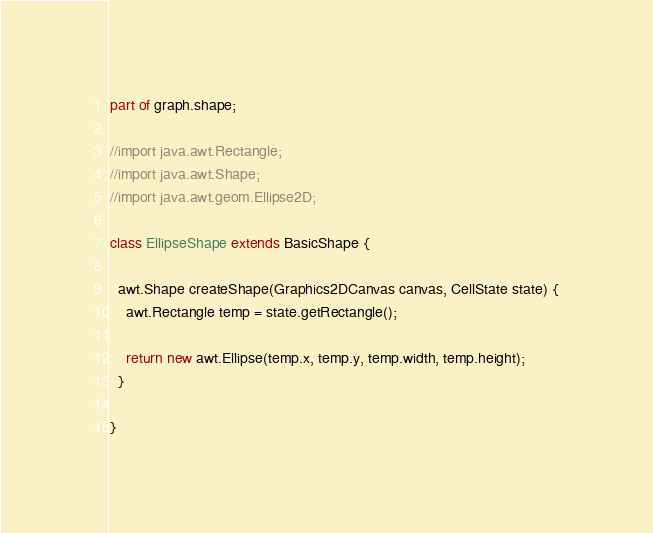Convert code to text. <code><loc_0><loc_0><loc_500><loc_500><_Dart_>part of graph.shape;

//import java.awt.Rectangle;
//import java.awt.Shape;
//import java.awt.geom.Ellipse2D;

class EllipseShape extends BasicShape {

  awt.Shape createShape(Graphics2DCanvas canvas, CellState state) {
    awt.Rectangle temp = state.getRectangle();

    return new awt.Ellipse(temp.x, temp.y, temp.width, temp.height);
  }

}
</code> 